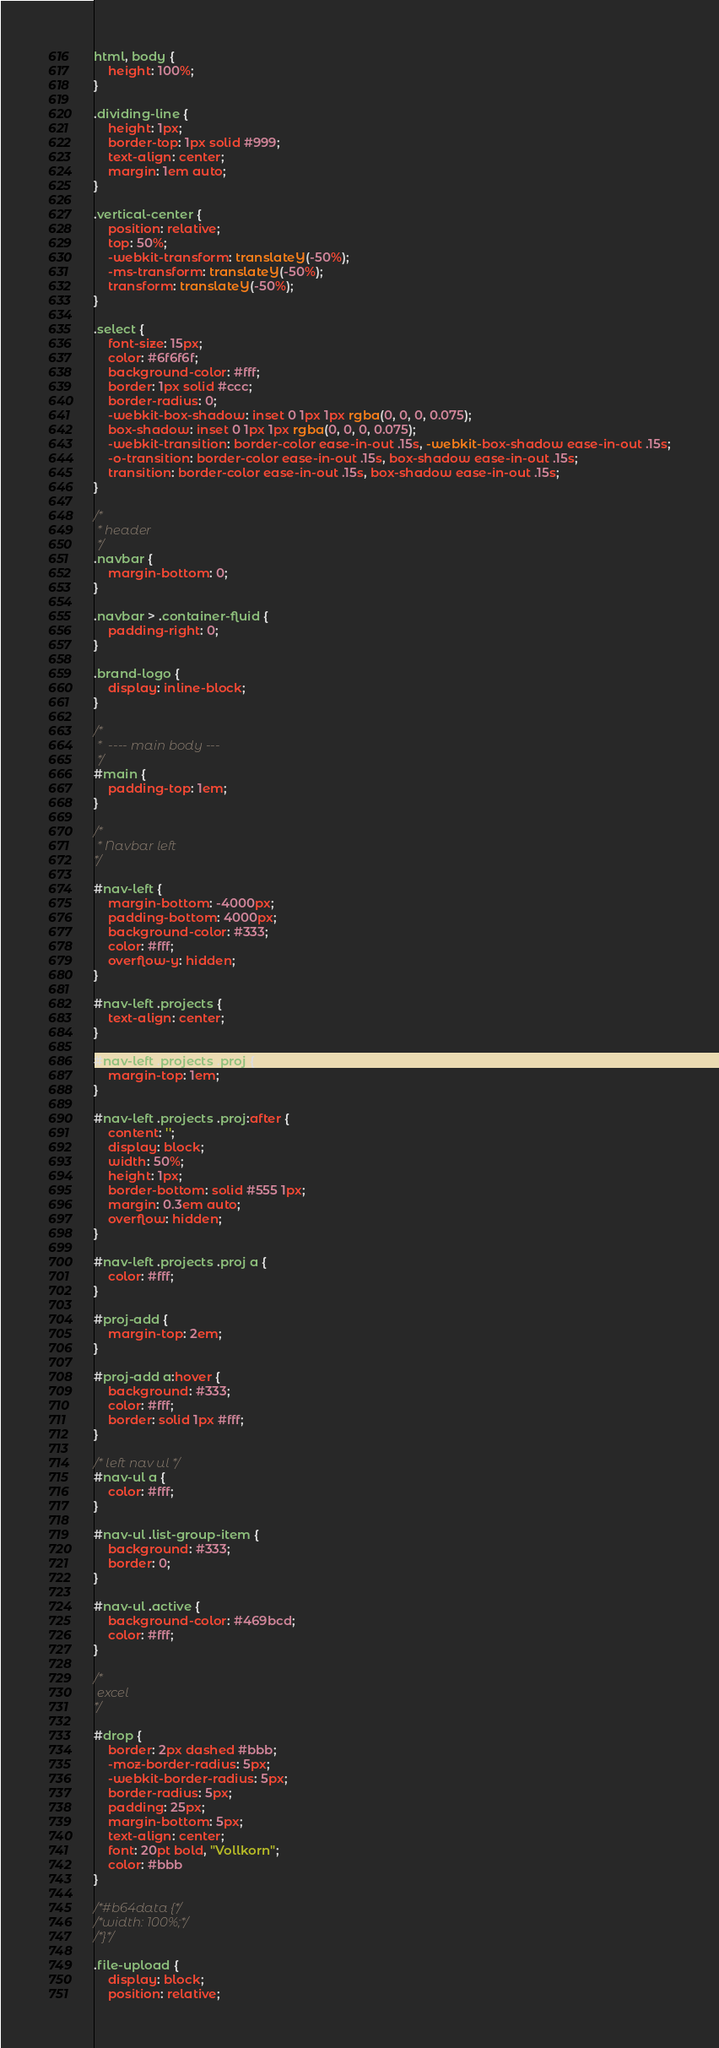Convert code to text. <code><loc_0><loc_0><loc_500><loc_500><_CSS_>html, body {
	height: 100%;
}

.dividing-line {
	height: 1px;
	border-top: 1px solid #999;
	text-align: center;
	margin: 1em auto;
}

.vertical-center {
	position: relative;
	top: 50%;
	-webkit-transform: translateY(-50%);
	-ms-transform: translateY(-50%);
	transform: translateY(-50%);
}

.select {
	font-size: 15px;
	color: #6f6f6f;
	background-color: #fff;
	border: 1px solid #ccc;
	border-radius: 0;
	-webkit-box-shadow: inset 0 1px 1px rgba(0, 0, 0, 0.075);
	box-shadow: inset 0 1px 1px rgba(0, 0, 0, 0.075);
	-webkit-transition: border-color ease-in-out .15s, -webkit-box-shadow ease-in-out .15s;
	-o-transition: border-color ease-in-out .15s, box-shadow ease-in-out .15s;
	transition: border-color ease-in-out .15s, box-shadow ease-in-out .15s;
}

/*
 * header
 */
.navbar {
	margin-bottom: 0;
}

.navbar > .container-fluid {
	padding-right: 0;
}

.brand-logo {
	display: inline-block;
}

/*
 *  ---- main body ---
 */
#main {
	padding-top: 1em;
}

/*
 * Navbar left
*/

#nav-left {
	margin-bottom: -4000px;
	padding-bottom: 4000px;
	background-color: #333;
	color: #fff;
	overflow-y: hidden;
}

#nav-left .projects {
	text-align: center;
}

#nav-left .projects .proj {
	margin-top: 1em;
}

#nav-left .projects .proj:after {
	content: '';
	display: block;
	width: 50%;
	height: 1px;
	border-bottom: solid #555 1px;
	margin: 0.3em auto;
	overflow: hidden;
}

#nav-left .projects .proj a {
	color: #fff;
}

#proj-add {
	margin-top: 2em;
}

#proj-add a:hover {
	background: #333;
	color: #fff;
	border: solid 1px #fff;
}

/* left nav ul */
#nav-ul a {
	color: #fff;
}

#nav-ul .list-group-item {
	background: #333;
	border: 0;
}

#nav-ul .active {
	background-color: #469bcd;
	color: #fff;
}

/*
 excel
*/

#drop {
	border: 2px dashed #bbb;
	-moz-border-radius: 5px;
	-webkit-border-radius: 5px;
	border-radius: 5px;
	padding: 25px;
	margin-bottom: 5px;
	text-align: center;
	font: 20pt bold, "Vollkorn";
	color: #bbb
}

/*#b64data {*/
/*width: 100%;*/
/*}*/

.file-upload {
	display: block;
	position: relative;</code> 